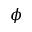<formula> <loc_0><loc_0><loc_500><loc_500>\phi</formula> 